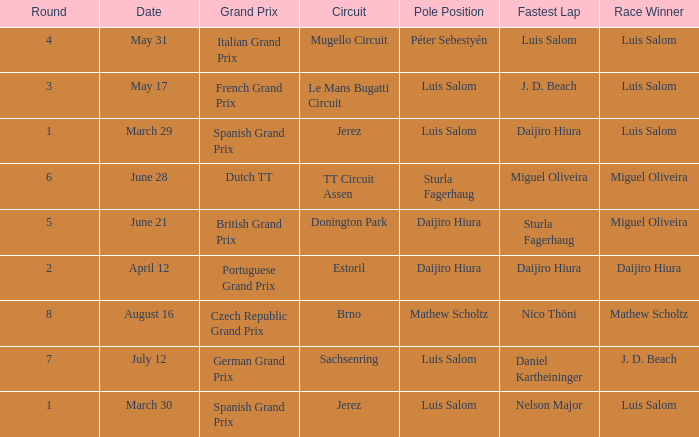Who had the fastest lap in the Dutch TT Grand Prix?  Miguel Oliveira. 